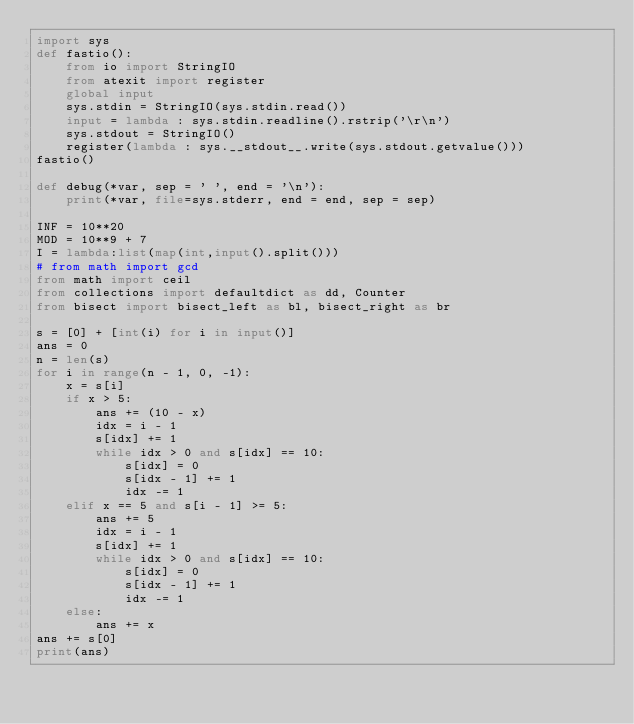Convert code to text. <code><loc_0><loc_0><loc_500><loc_500><_Python_>import sys
def fastio():
    from io import StringIO
    from atexit import register
    global input
    sys.stdin = StringIO(sys.stdin.read())
    input = lambda : sys.stdin.readline().rstrip('\r\n')
    sys.stdout = StringIO()
    register(lambda : sys.__stdout__.write(sys.stdout.getvalue()))
fastio()

def debug(*var, sep = ' ', end = '\n'):
    print(*var, file=sys.stderr, end = end, sep = sep)

INF = 10**20
MOD = 10**9 + 7
I = lambda:list(map(int,input().split()))
# from math import gcd
from math import ceil
from collections import defaultdict as dd, Counter
from bisect import bisect_left as bl, bisect_right as br

s = [0] + [int(i) for i in input()]
ans = 0
n = len(s)
for i in range(n - 1, 0, -1):
    x = s[i]
    if x > 5:
        ans += (10 - x)
        idx = i - 1
        s[idx] += 1
        while idx > 0 and s[idx] == 10:
            s[idx] = 0
            s[idx - 1] += 1
            idx -= 1
    elif x == 5 and s[i - 1] >= 5:
        ans += 5
        idx = i - 1
        s[idx] += 1
        while idx > 0 and s[idx] == 10:
            s[idx] = 0
            s[idx - 1] += 1
            idx -= 1
    else:
        ans += x
ans += s[0]
print(ans)
</code> 